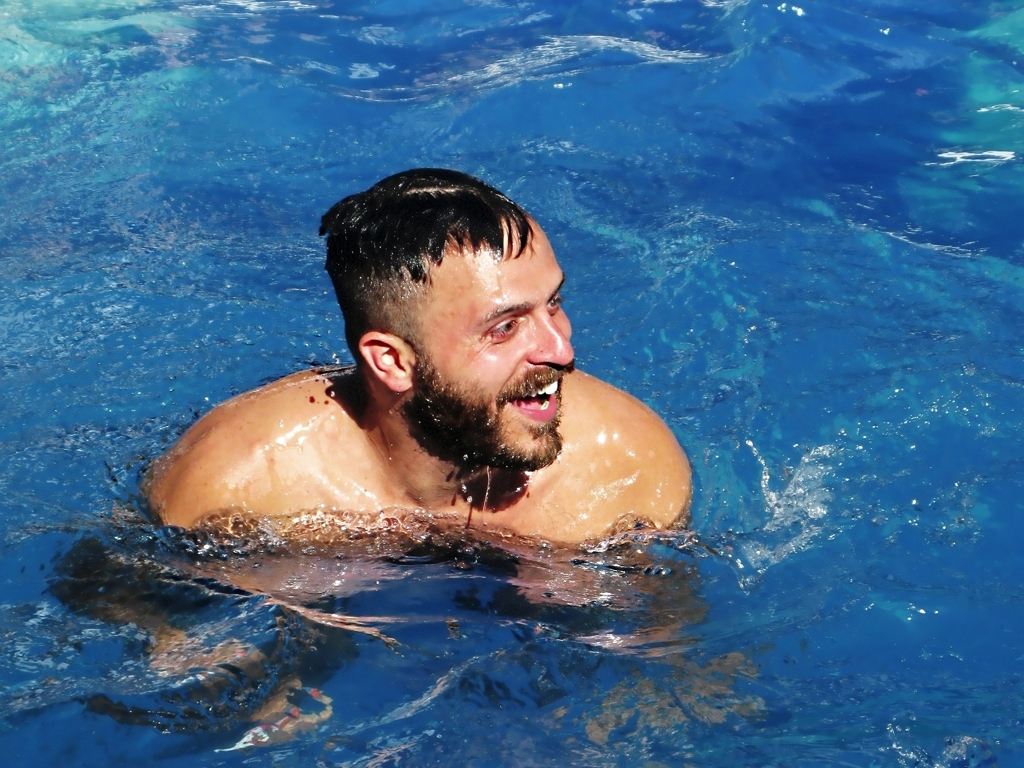What are the characteristics of the lighting in this image? The lighting in the image appears to be natural, as evidenced by the bright and vivid tones of the water, which suggest sunlight. There are strong highlights on the water's surface and on the man's shoulders, indicating the presence of a strong light source from above, likely the sun. The clarity and intensity of the lighting contribute to the perception of a sunny day, ideal for outdoor swimming. 